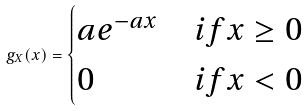Convert formula to latex. <formula><loc_0><loc_0><loc_500><loc_500>g _ { X } ( x ) = \begin{cases} a e ^ { - a x } & i f x \geq 0 \\ 0 & i f x < 0 \end{cases}</formula> 